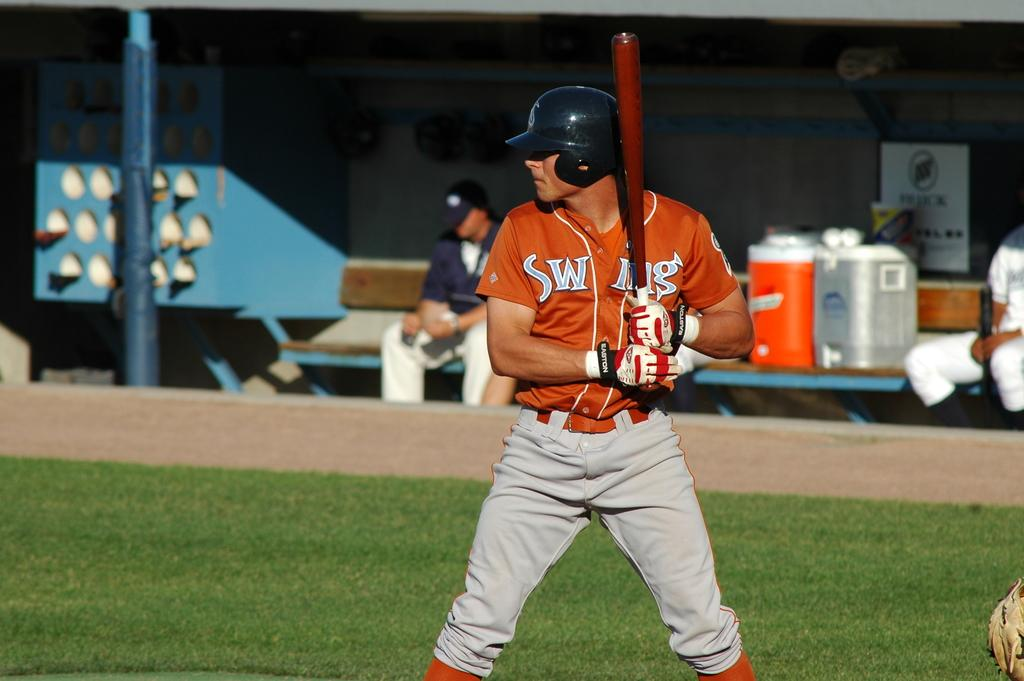<image>
Write a terse but informative summary of the picture. A baseball batter's shirt, which appears to say "Swing", is partly covered by his bat. 